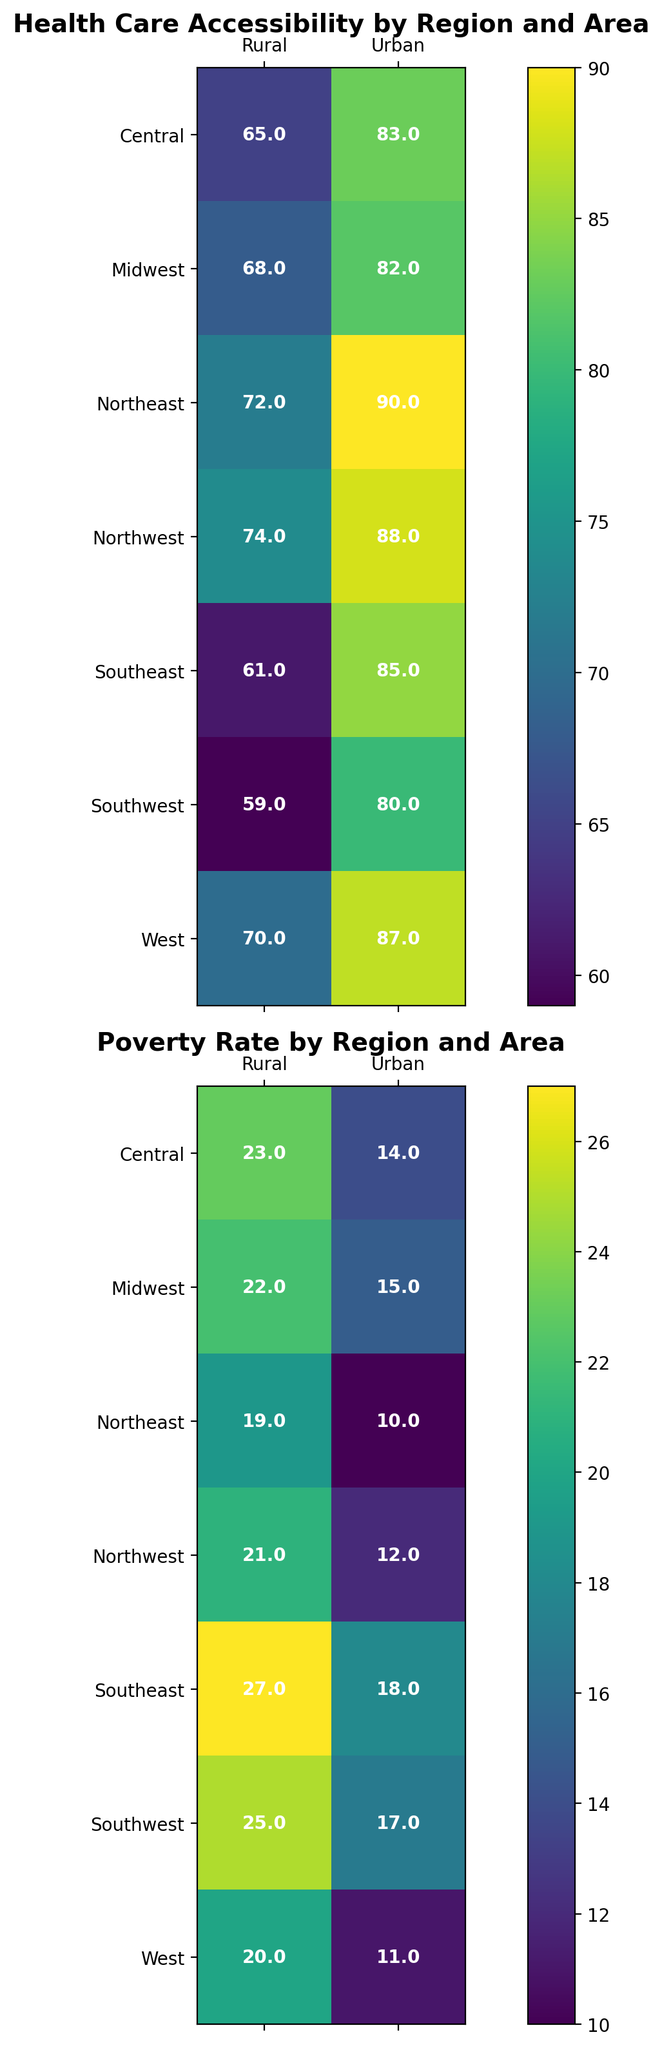What is the difference in Health Care Accessibility between Urban and Rural areas in the Northeast? From the heatmap for Health Care Accessibility, the value for Urban areas in the Northeast is 90, and for Rural areas, it is 72. The difference is calculated as 90 - 72.
Answer: 18 Which area, Urban or Rural, in the Midwest has a higher Poverty Rate? Looking at the heatmap for Poverty Rate, Urban areas in the Midwest have a value of 15, while Rural areas have a value of 22. Since 22 is greater than 15, Rural areas have a higher Poverty Rate.
Answer: Rural What is the average Poverty Rate in Rural areas across all regions? Summing the Poverty Rates in Rural areas (21, 27, 22, 19, 25, 23, 20) and dividing by the number of regions (7): (21+27+22+19+25+23+20) / 7 = 157 / 7.
Answer: 22.4 In which region is Health Care Accessibility the lowest for Urban areas? Observing the heatmap for Health Care Accessibility, the lowest value for Urban areas is in the Southwest, which is 80.
Answer: Southwest By how much does the Poverty Rate in Urban areas of the Southeast exceed that in Urban areas of the Northeast? The Poverty Rate for Urban areas in the Southeast is 18, and in the Northeast, it is 10. The difference is 18 - 10.
Answer: 8 Which region shows the greatest disparity in Poverty Rate between Urban and Rural areas? Calculating the difference in Poverty Rates for each region:
Northwest: 21 - 12 = 9
Southeast: 27 - 18 = 9
Midwest: 22 - 15 = 7
Northeast: 19 - 10 = 9
Southwest: 25 - 17 = 8
Central: 23 - 14 = 9
West: 20 - 11 = 9
Multiple regions have the same maximum disparity of 9, but since we are looking for a singular region, let's consider the first occurrence, which is the Northwest.
Answer: Northwest Compare the Health Care Accessibility between Urban areas in the Southeast and the Central region. The heatmap for Health Care Accessibility shows that Urban areas in the Southeast have a value of 85, and in the Central region, it is 83. Since 85 is greater than 83, the Southeast has higher Health Care Accessibility.
Answer: Southeast What is the total Health Care Accessibility score for Rural areas across all regions? Summing the Health Care Accessibility values in Rural areas (74, 61, 68, 72, 59, 65, 70): 74 + 61 + 68 + 72 + 59 + 65 + 70 = 469
Answer: 469 